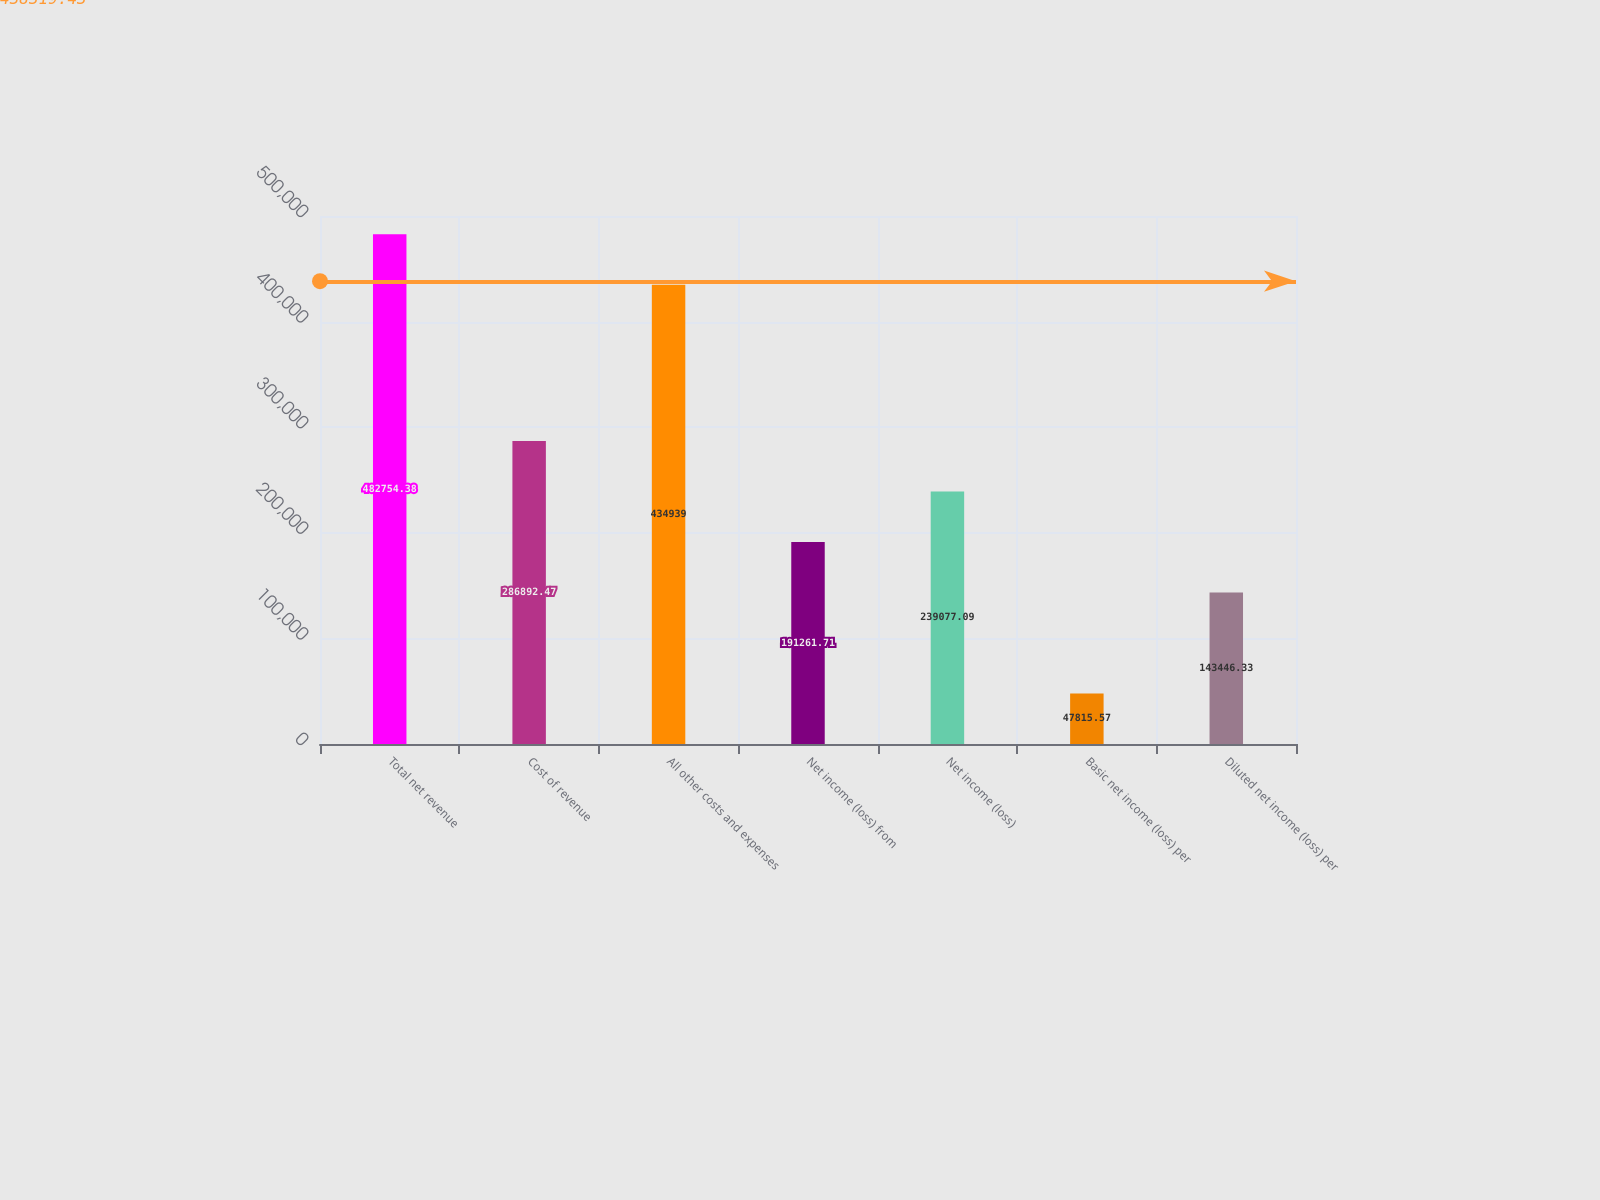Convert chart to OTSL. <chart><loc_0><loc_0><loc_500><loc_500><bar_chart><fcel>Total net revenue<fcel>Cost of revenue<fcel>All other costs and expenses<fcel>Net income (loss) from<fcel>Net income (loss)<fcel>Basic net income (loss) per<fcel>Diluted net income (loss) per<nl><fcel>482754<fcel>286892<fcel>434939<fcel>191262<fcel>239077<fcel>47815.6<fcel>143446<nl></chart> 